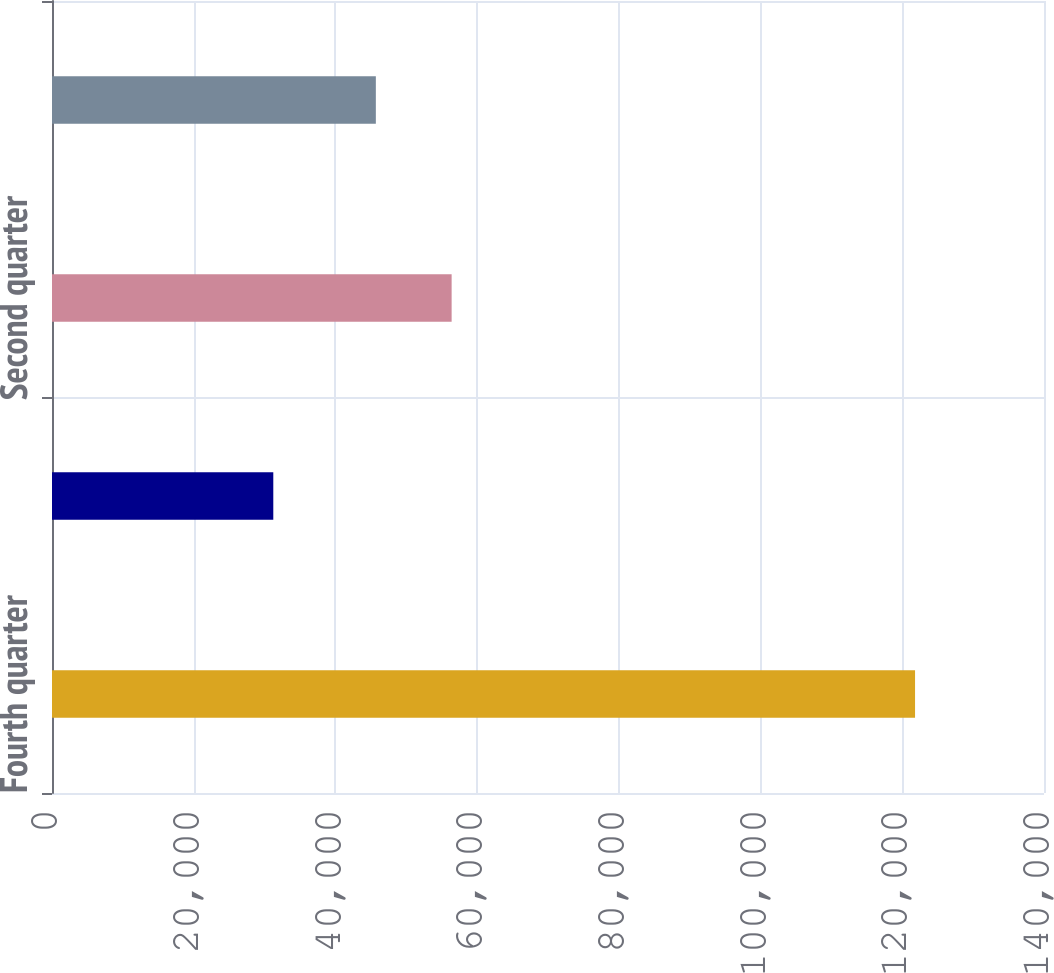<chart> <loc_0><loc_0><loc_500><loc_500><bar_chart><fcel>Fourth quarter<fcel>Third quarter<fcel>Second quarter<fcel>First quarter<nl><fcel>121802<fcel>31231<fcel>56400<fcel>45704<nl></chart> 